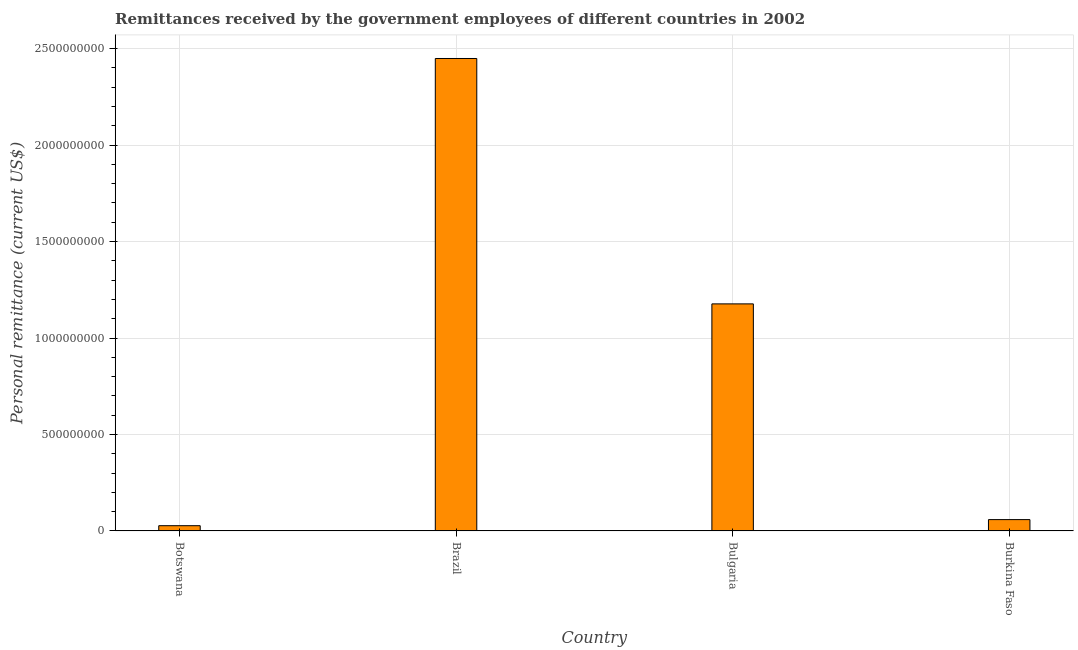Does the graph contain grids?
Offer a very short reply. Yes. What is the title of the graph?
Your answer should be compact. Remittances received by the government employees of different countries in 2002. What is the label or title of the Y-axis?
Provide a succinct answer. Personal remittance (current US$). What is the personal remittances in Brazil?
Your answer should be compact. 2.45e+09. Across all countries, what is the maximum personal remittances?
Give a very brief answer. 2.45e+09. Across all countries, what is the minimum personal remittances?
Make the answer very short. 2.72e+07. In which country was the personal remittances maximum?
Your answer should be compact. Brazil. In which country was the personal remittances minimum?
Your answer should be compact. Botswana. What is the sum of the personal remittances?
Ensure brevity in your answer.  3.71e+09. What is the difference between the personal remittances in Bulgaria and Burkina Faso?
Offer a very short reply. 1.12e+09. What is the average personal remittances per country?
Ensure brevity in your answer.  9.28e+08. What is the median personal remittances?
Offer a very short reply. 6.18e+08. What is the ratio of the personal remittances in Bulgaria to that in Burkina Faso?
Your answer should be very brief. 20.04. Is the personal remittances in Bulgaria less than that in Burkina Faso?
Your answer should be very brief. No. What is the difference between the highest and the second highest personal remittances?
Provide a succinct answer. 1.27e+09. Is the sum of the personal remittances in Bulgaria and Burkina Faso greater than the maximum personal remittances across all countries?
Keep it short and to the point. No. What is the difference between the highest and the lowest personal remittances?
Offer a very short reply. 2.42e+09. In how many countries, is the personal remittances greater than the average personal remittances taken over all countries?
Offer a terse response. 2. What is the difference between two consecutive major ticks on the Y-axis?
Your answer should be compact. 5.00e+08. Are the values on the major ticks of Y-axis written in scientific E-notation?
Your answer should be compact. No. What is the Personal remittance (current US$) in Botswana?
Make the answer very short. 2.72e+07. What is the Personal remittance (current US$) in Brazil?
Your answer should be very brief. 2.45e+09. What is the Personal remittance (current US$) in Bulgaria?
Your response must be concise. 1.18e+09. What is the Personal remittance (current US$) of Burkina Faso?
Your answer should be very brief. 5.87e+07. What is the difference between the Personal remittance (current US$) in Botswana and Brazil?
Keep it short and to the point. -2.42e+09. What is the difference between the Personal remittance (current US$) in Botswana and Bulgaria?
Provide a succinct answer. -1.15e+09. What is the difference between the Personal remittance (current US$) in Botswana and Burkina Faso?
Your answer should be very brief. -3.16e+07. What is the difference between the Personal remittance (current US$) in Brazil and Bulgaria?
Keep it short and to the point. 1.27e+09. What is the difference between the Personal remittance (current US$) in Brazil and Burkina Faso?
Your answer should be very brief. 2.39e+09. What is the difference between the Personal remittance (current US$) in Bulgaria and Burkina Faso?
Provide a short and direct response. 1.12e+09. What is the ratio of the Personal remittance (current US$) in Botswana to that in Brazil?
Give a very brief answer. 0.01. What is the ratio of the Personal remittance (current US$) in Botswana to that in Bulgaria?
Ensure brevity in your answer.  0.02. What is the ratio of the Personal remittance (current US$) in Botswana to that in Burkina Faso?
Give a very brief answer. 0.46. What is the ratio of the Personal remittance (current US$) in Brazil to that in Bulgaria?
Provide a short and direct response. 2.08. What is the ratio of the Personal remittance (current US$) in Brazil to that in Burkina Faso?
Provide a succinct answer. 41.7. What is the ratio of the Personal remittance (current US$) in Bulgaria to that in Burkina Faso?
Keep it short and to the point. 20.04. 